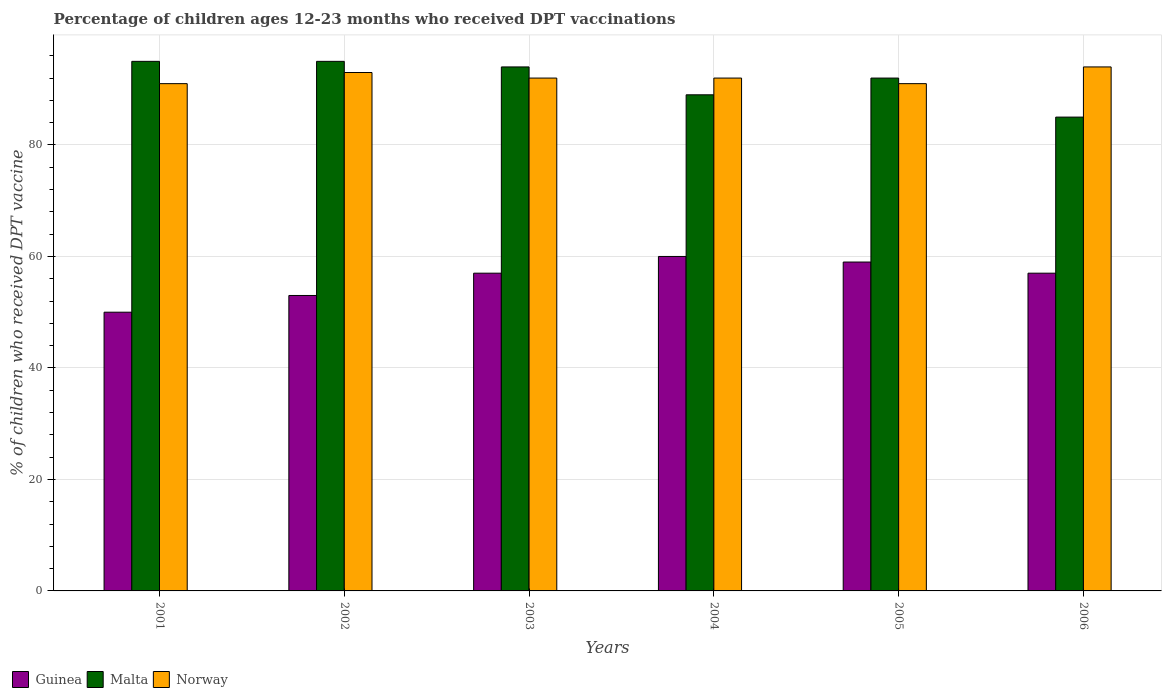How many different coloured bars are there?
Ensure brevity in your answer.  3. Are the number of bars per tick equal to the number of legend labels?
Offer a very short reply. Yes. How many bars are there on the 4th tick from the right?
Provide a succinct answer. 3. What is the label of the 5th group of bars from the left?
Your answer should be compact. 2005. What is the percentage of children who received DPT vaccination in Norway in 2003?
Offer a very short reply. 92. Across all years, what is the maximum percentage of children who received DPT vaccination in Norway?
Offer a terse response. 94. Across all years, what is the minimum percentage of children who received DPT vaccination in Norway?
Keep it short and to the point. 91. In which year was the percentage of children who received DPT vaccination in Guinea minimum?
Your response must be concise. 2001. What is the total percentage of children who received DPT vaccination in Norway in the graph?
Provide a short and direct response. 553. What is the difference between the percentage of children who received DPT vaccination in Norway in 2005 and that in 2006?
Your response must be concise. -3. What is the difference between the percentage of children who received DPT vaccination in Norway in 2001 and the percentage of children who received DPT vaccination in Guinea in 2004?
Your response must be concise. 31. What is the average percentage of children who received DPT vaccination in Norway per year?
Offer a very short reply. 92.17. In the year 2005, what is the difference between the percentage of children who received DPT vaccination in Norway and percentage of children who received DPT vaccination in Malta?
Provide a succinct answer. -1. What is the ratio of the percentage of children who received DPT vaccination in Guinea in 2001 to that in 2003?
Your answer should be very brief. 0.88. What is the difference between the highest and the second highest percentage of children who received DPT vaccination in Malta?
Ensure brevity in your answer.  0. Is the sum of the percentage of children who received DPT vaccination in Guinea in 2001 and 2002 greater than the maximum percentage of children who received DPT vaccination in Norway across all years?
Provide a succinct answer. Yes. What does the 2nd bar from the left in 2005 represents?
Offer a terse response. Malta. What does the 3rd bar from the right in 2003 represents?
Provide a succinct answer. Guinea. Are all the bars in the graph horizontal?
Make the answer very short. No. How many years are there in the graph?
Your answer should be very brief. 6. Does the graph contain any zero values?
Provide a short and direct response. No. Does the graph contain grids?
Keep it short and to the point. Yes. How many legend labels are there?
Your answer should be compact. 3. How are the legend labels stacked?
Your answer should be compact. Horizontal. What is the title of the graph?
Your answer should be compact. Percentage of children ages 12-23 months who received DPT vaccinations. What is the label or title of the X-axis?
Provide a short and direct response. Years. What is the label or title of the Y-axis?
Provide a succinct answer. % of children who received DPT vaccine. What is the % of children who received DPT vaccine in Malta in 2001?
Your response must be concise. 95. What is the % of children who received DPT vaccine of Norway in 2001?
Offer a terse response. 91. What is the % of children who received DPT vaccine in Guinea in 2002?
Your answer should be compact. 53. What is the % of children who received DPT vaccine of Malta in 2002?
Ensure brevity in your answer.  95. What is the % of children who received DPT vaccine in Norway in 2002?
Provide a succinct answer. 93. What is the % of children who received DPT vaccine in Guinea in 2003?
Your answer should be compact. 57. What is the % of children who received DPT vaccine of Malta in 2003?
Give a very brief answer. 94. What is the % of children who received DPT vaccine in Norway in 2003?
Make the answer very short. 92. What is the % of children who received DPT vaccine of Guinea in 2004?
Keep it short and to the point. 60. What is the % of children who received DPT vaccine of Malta in 2004?
Give a very brief answer. 89. What is the % of children who received DPT vaccine of Norway in 2004?
Provide a succinct answer. 92. What is the % of children who received DPT vaccine of Guinea in 2005?
Give a very brief answer. 59. What is the % of children who received DPT vaccine of Malta in 2005?
Ensure brevity in your answer.  92. What is the % of children who received DPT vaccine in Norway in 2005?
Keep it short and to the point. 91. What is the % of children who received DPT vaccine of Malta in 2006?
Your answer should be very brief. 85. What is the % of children who received DPT vaccine in Norway in 2006?
Ensure brevity in your answer.  94. Across all years, what is the maximum % of children who received DPT vaccine of Guinea?
Offer a terse response. 60. Across all years, what is the maximum % of children who received DPT vaccine of Norway?
Give a very brief answer. 94. Across all years, what is the minimum % of children who received DPT vaccine of Guinea?
Your response must be concise. 50. Across all years, what is the minimum % of children who received DPT vaccine in Norway?
Your response must be concise. 91. What is the total % of children who received DPT vaccine of Guinea in the graph?
Offer a very short reply. 336. What is the total % of children who received DPT vaccine of Malta in the graph?
Your response must be concise. 550. What is the total % of children who received DPT vaccine of Norway in the graph?
Your answer should be compact. 553. What is the difference between the % of children who received DPT vaccine of Malta in 2001 and that in 2002?
Give a very brief answer. 0. What is the difference between the % of children who received DPT vaccine of Malta in 2001 and that in 2003?
Offer a very short reply. 1. What is the difference between the % of children who received DPT vaccine of Norway in 2001 and that in 2003?
Provide a short and direct response. -1. What is the difference between the % of children who received DPT vaccine in Malta in 2001 and that in 2004?
Provide a succinct answer. 6. What is the difference between the % of children who received DPT vaccine of Guinea in 2001 and that in 2006?
Give a very brief answer. -7. What is the difference between the % of children who received DPT vaccine in Norway in 2001 and that in 2006?
Provide a short and direct response. -3. What is the difference between the % of children who received DPT vaccine of Malta in 2002 and that in 2004?
Keep it short and to the point. 6. What is the difference between the % of children who received DPT vaccine in Guinea in 2002 and that in 2005?
Offer a very short reply. -6. What is the difference between the % of children who received DPT vaccine in Guinea in 2002 and that in 2006?
Offer a very short reply. -4. What is the difference between the % of children who received DPT vaccine in Norway in 2002 and that in 2006?
Offer a very short reply. -1. What is the difference between the % of children who received DPT vaccine in Malta in 2003 and that in 2004?
Provide a succinct answer. 5. What is the difference between the % of children who received DPT vaccine of Norway in 2003 and that in 2004?
Provide a short and direct response. 0. What is the difference between the % of children who received DPT vaccine in Malta in 2003 and that in 2005?
Provide a short and direct response. 2. What is the difference between the % of children who received DPT vaccine in Guinea in 2003 and that in 2006?
Your response must be concise. 0. What is the difference between the % of children who received DPT vaccine in Malta in 2003 and that in 2006?
Your response must be concise. 9. What is the difference between the % of children who received DPT vaccine in Norway in 2003 and that in 2006?
Keep it short and to the point. -2. What is the difference between the % of children who received DPT vaccine in Malta in 2004 and that in 2005?
Offer a very short reply. -3. What is the difference between the % of children who received DPT vaccine in Norway in 2004 and that in 2006?
Your response must be concise. -2. What is the difference between the % of children who received DPT vaccine in Guinea in 2005 and that in 2006?
Keep it short and to the point. 2. What is the difference between the % of children who received DPT vaccine in Malta in 2005 and that in 2006?
Ensure brevity in your answer.  7. What is the difference between the % of children who received DPT vaccine of Norway in 2005 and that in 2006?
Your answer should be compact. -3. What is the difference between the % of children who received DPT vaccine of Guinea in 2001 and the % of children who received DPT vaccine of Malta in 2002?
Provide a succinct answer. -45. What is the difference between the % of children who received DPT vaccine in Guinea in 2001 and the % of children who received DPT vaccine in Norway in 2002?
Provide a succinct answer. -43. What is the difference between the % of children who received DPT vaccine of Malta in 2001 and the % of children who received DPT vaccine of Norway in 2002?
Offer a very short reply. 2. What is the difference between the % of children who received DPT vaccine of Guinea in 2001 and the % of children who received DPT vaccine of Malta in 2003?
Provide a short and direct response. -44. What is the difference between the % of children who received DPT vaccine in Guinea in 2001 and the % of children who received DPT vaccine in Norway in 2003?
Make the answer very short. -42. What is the difference between the % of children who received DPT vaccine in Guinea in 2001 and the % of children who received DPT vaccine in Malta in 2004?
Provide a succinct answer. -39. What is the difference between the % of children who received DPT vaccine in Guinea in 2001 and the % of children who received DPT vaccine in Norway in 2004?
Make the answer very short. -42. What is the difference between the % of children who received DPT vaccine of Malta in 2001 and the % of children who received DPT vaccine of Norway in 2004?
Your answer should be very brief. 3. What is the difference between the % of children who received DPT vaccine of Guinea in 2001 and the % of children who received DPT vaccine of Malta in 2005?
Provide a succinct answer. -42. What is the difference between the % of children who received DPT vaccine of Guinea in 2001 and the % of children who received DPT vaccine of Norway in 2005?
Offer a very short reply. -41. What is the difference between the % of children who received DPT vaccine of Malta in 2001 and the % of children who received DPT vaccine of Norway in 2005?
Make the answer very short. 4. What is the difference between the % of children who received DPT vaccine of Guinea in 2001 and the % of children who received DPT vaccine of Malta in 2006?
Keep it short and to the point. -35. What is the difference between the % of children who received DPT vaccine of Guinea in 2001 and the % of children who received DPT vaccine of Norway in 2006?
Offer a terse response. -44. What is the difference between the % of children who received DPT vaccine in Malta in 2001 and the % of children who received DPT vaccine in Norway in 2006?
Give a very brief answer. 1. What is the difference between the % of children who received DPT vaccine in Guinea in 2002 and the % of children who received DPT vaccine in Malta in 2003?
Your response must be concise. -41. What is the difference between the % of children who received DPT vaccine of Guinea in 2002 and the % of children who received DPT vaccine of Norway in 2003?
Give a very brief answer. -39. What is the difference between the % of children who received DPT vaccine in Malta in 2002 and the % of children who received DPT vaccine in Norway in 2003?
Offer a very short reply. 3. What is the difference between the % of children who received DPT vaccine in Guinea in 2002 and the % of children who received DPT vaccine in Malta in 2004?
Your response must be concise. -36. What is the difference between the % of children who received DPT vaccine in Guinea in 2002 and the % of children who received DPT vaccine in Norway in 2004?
Provide a short and direct response. -39. What is the difference between the % of children who received DPT vaccine of Malta in 2002 and the % of children who received DPT vaccine of Norway in 2004?
Keep it short and to the point. 3. What is the difference between the % of children who received DPT vaccine in Guinea in 2002 and the % of children who received DPT vaccine in Malta in 2005?
Give a very brief answer. -39. What is the difference between the % of children who received DPT vaccine of Guinea in 2002 and the % of children who received DPT vaccine of Norway in 2005?
Your answer should be very brief. -38. What is the difference between the % of children who received DPT vaccine of Malta in 2002 and the % of children who received DPT vaccine of Norway in 2005?
Keep it short and to the point. 4. What is the difference between the % of children who received DPT vaccine in Guinea in 2002 and the % of children who received DPT vaccine in Malta in 2006?
Offer a terse response. -32. What is the difference between the % of children who received DPT vaccine in Guinea in 2002 and the % of children who received DPT vaccine in Norway in 2006?
Provide a succinct answer. -41. What is the difference between the % of children who received DPT vaccine in Malta in 2002 and the % of children who received DPT vaccine in Norway in 2006?
Provide a succinct answer. 1. What is the difference between the % of children who received DPT vaccine in Guinea in 2003 and the % of children who received DPT vaccine in Malta in 2004?
Make the answer very short. -32. What is the difference between the % of children who received DPT vaccine of Guinea in 2003 and the % of children who received DPT vaccine of Norway in 2004?
Ensure brevity in your answer.  -35. What is the difference between the % of children who received DPT vaccine in Malta in 2003 and the % of children who received DPT vaccine in Norway in 2004?
Offer a terse response. 2. What is the difference between the % of children who received DPT vaccine in Guinea in 2003 and the % of children who received DPT vaccine in Malta in 2005?
Provide a succinct answer. -35. What is the difference between the % of children who received DPT vaccine of Guinea in 2003 and the % of children who received DPT vaccine of Norway in 2005?
Give a very brief answer. -34. What is the difference between the % of children who received DPT vaccine of Guinea in 2003 and the % of children who received DPT vaccine of Norway in 2006?
Keep it short and to the point. -37. What is the difference between the % of children who received DPT vaccine in Malta in 2003 and the % of children who received DPT vaccine in Norway in 2006?
Your response must be concise. 0. What is the difference between the % of children who received DPT vaccine in Guinea in 2004 and the % of children who received DPT vaccine in Malta in 2005?
Offer a very short reply. -32. What is the difference between the % of children who received DPT vaccine of Guinea in 2004 and the % of children who received DPT vaccine of Norway in 2005?
Your answer should be compact. -31. What is the difference between the % of children who received DPT vaccine of Malta in 2004 and the % of children who received DPT vaccine of Norway in 2005?
Your answer should be compact. -2. What is the difference between the % of children who received DPT vaccine in Guinea in 2004 and the % of children who received DPT vaccine in Norway in 2006?
Keep it short and to the point. -34. What is the difference between the % of children who received DPT vaccine in Malta in 2004 and the % of children who received DPT vaccine in Norway in 2006?
Your answer should be very brief. -5. What is the difference between the % of children who received DPT vaccine in Guinea in 2005 and the % of children who received DPT vaccine in Norway in 2006?
Your response must be concise. -35. What is the difference between the % of children who received DPT vaccine of Malta in 2005 and the % of children who received DPT vaccine of Norway in 2006?
Your answer should be very brief. -2. What is the average % of children who received DPT vaccine of Guinea per year?
Your answer should be very brief. 56. What is the average % of children who received DPT vaccine in Malta per year?
Offer a terse response. 91.67. What is the average % of children who received DPT vaccine of Norway per year?
Provide a short and direct response. 92.17. In the year 2001, what is the difference between the % of children who received DPT vaccine of Guinea and % of children who received DPT vaccine of Malta?
Give a very brief answer. -45. In the year 2001, what is the difference between the % of children who received DPT vaccine of Guinea and % of children who received DPT vaccine of Norway?
Offer a terse response. -41. In the year 2001, what is the difference between the % of children who received DPT vaccine of Malta and % of children who received DPT vaccine of Norway?
Give a very brief answer. 4. In the year 2002, what is the difference between the % of children who received DPT vaccine of Guinea and % of children who received DPT vaccine of Malta?
Offer a terse response. -42. In the year 2002, what is the difference between the % of children who received DPT vaccine in Malta and % of children who received DPT vaccine in Norway?
Your response must be concise. 2. In the year 2003, what is the difference between the % of children who received DPT vaccine of Guinea and % of children who received DPT vaccine of Malta?
Give a very brief answer. -37. In the year 2003, what is the difference between the % of children who received DPT vaccine of Guinea and % of children who received DPT vaccine of Norway?
Offer a terse response. -35. In the year 2003, what is the difference between the % of children who received DPT vaccine in Malta and % of children who received DPT vaccine in Norway?
Make the answer very short. 2. In the year 2004, what is the difference between the % of children who received DPT vaccine of Guinea and % of children who received DPT vaccine of Norway?
Offer a very short reply. -32. In the year 2004, what is the difference between the % of children who received DPT vaccine of Malta and % of children who received DPT vaccine of Norway?
Keep it short and to the point. -3. In the year 2005, what is the difference between the % of children who received DPT vaccine of Guinea and % of children who received DPT vaccine of Malta?
Your answer should be compact. -33. In the year 2005, what is the difference between the % of children who received DPT vaccine in Guinea and % of children who received DPT vaccine in Norway?
Offer a very short reply. -32. In the year 2006, what is the difference between the % of children who received DPT vaccine of Guinea and % of children who received DPT vaccine of Norway?
Make the answer very short. -37. In the year 2006, what is the difference between the % of children who received DPT vaccine of Malta and % of children who received DPT vaccine of Norway?
Keep it short and to the point. -9. What is the ratio of the % of children who received DPT vaccine in Guinea in 2001 to that in 2002?
Offer a very short reply. 0.94. What is the ratio of the % of children who received DPT vaccine of Norway in 2001 to that in 2002?
Make the answer very short. 0.98. What is the ratio of the % of children who received DPT vaccine of Guinea in 2001 to that in 2003?
Make the answer very short. 0.88. What is the ratio of the % of children who received DPT vaccine of Malta in 2001 to that in 2003?
Your response must be concise. 1.01. What is the ratio of the % of children who received DPT vaccine of Guinea in 2001 to that in 2004?
Make the answer very short. 0.83. What is the ratio of the % of children who received DPT vaccine in Malta in 2001 to that in 2004?
Make the answer very short. 1.07. What is the ratio of the % of children who received DPT vaccine of Norway in 2001 to that in 2004?
Ensure brevity in your answer.  0.99. What is the ratio of the % of children who received DPT vaccine in Guinea in 2001 to that in 2005?
Make the answer very short. 0.85. What is the ratio of the % of children who received DPT vaccine of Malta in 2001 to that in 2005?
Give a very brief answer. 1.03. What is the ratio of the % of children who received DPT vaccine of Guinea in 2001 to that in 2006?
Ensure brevity in your answer.  0.88. What is the ratio of the % of children who received DPT vaccine of Malta in 2001 to that in 2006?
Offer a terse response. 1.12. What is the ratio of the % of children who received DPT vaccine of Norway in 2001 to that in 2006?
Provide a succinct answer. 0.97. What is the ratio of the % of children who received DPT vaccine in Guinea in 2002 to that in 2003?
Keep it short and to the point. 0.93. What is the ratio of the % of children who received DPT vaccine in Malta in 2002 to that in 2003?
Make the answer very short. 1.01. What is the ratio of the % of children who received DPT vaccine of Norway in 2002 to that in 2003?
Ensure brevity in your answer.  1.01. What is the ratio of the % of children who received DPT vaccine in Guinea in 2002 to that in 2004?
Keep it short and to the point. 0.88. What is the ratio of the % of children who received DPT vaccine of Malta in 2002 to that in 2004?
Give a very brief answer. 1.07. What is the ratio of the % of children who received DPT vaccine of Norway in 2002 to that in 2004?
Offer a terse response. 1.01. What is the ratio of the % of children who received DPT vaccine of Guinea in 2002 to that in 2005?
Ensure brevity in your answer.  0.9. What is the ratio of the % of children who received DPT vaccine of Malta in 2002 to that in 2005?
Your answer should be compact. 1.03. What is the ratio of the % of children who received DPT vaccine in Guinea in 2002 to that in 2006?
Offer a very short reply. 0.93. What is the ratio of the % of children who received DPT vaccine in Malta in 2002 to that in 2006?
Your response must be concise. 1.12. What is the ratio of the % of children who received DPT vaccine in Malta in 2003 to that in 2004?
Make the answer very short. 1.06. What is the ratio of the % of children who received DPT vaccine in Norway in 2003 to that in 2004?
Give a very brief answer. 1. What is the ratio of the % of children who received DPT vaccine of Guinea in 2003 to that in 2005?
Provide a succinct answer. 0.97. What is the ratio of the % of children who received DPT vaccine in Malta in 2003 to that in 2005?
Your answer should be compact. 1.02. What is the ratio of the % of children who received DPT vaccine of Norway in 2003 to that in 2005?
Your response must be concise. 1.01. What is the ratio of the % of children who received DPT vaccine of Malta in 2003 to that in 2006?
Make the answer very short. 1.11. What is the ratio of the % of children who received DPT vaccine in Norway in 2003 to that in 2006?
Make the answer very short. 0.98. What is the ratio of the % of children who received DPT vaccine of Guinea in 2004 to that in 2005?
Give a very brief answer. 1.02. What is the ratio of the % of children who received DPT vaccine of Malta in 2004 to that in 2005?
Your answer should be very brief. 0.97. What is the ratio of the % of children who received DPT vaccine of Norway in 2004 to that in 2005?
Give a very brief answer. 1.01. What is the ratio of the % of children who received DPT vaccine of Guinea in 2004 to that in 2006?
Give a very brief answer. 1.05. What is the ratio of the % of children who received DPT vaccine in Malta in 2004 to that in 2006?
Ensure brevity in your answer.  1.05. What is the ratio of the % of children who received DPT vaccine in Norway in 2004 to that in 2006?
Provide a succinct answer. 0.98. What is the ratio of the % of children who received DPT vaccine in Guinea in 2005 to that in 2006?
Ensure brevity in your answer.  1.04. What is the ratio of the % of children who received DPT vaccine of Malta in 2005 to that in 2006?
Keep it short and to the point. 1.08. What is the ratio of the % of children who received DPT vaccine of Norway in 2005 to that in 2006?
Provide a short and direct response. 0.97. 